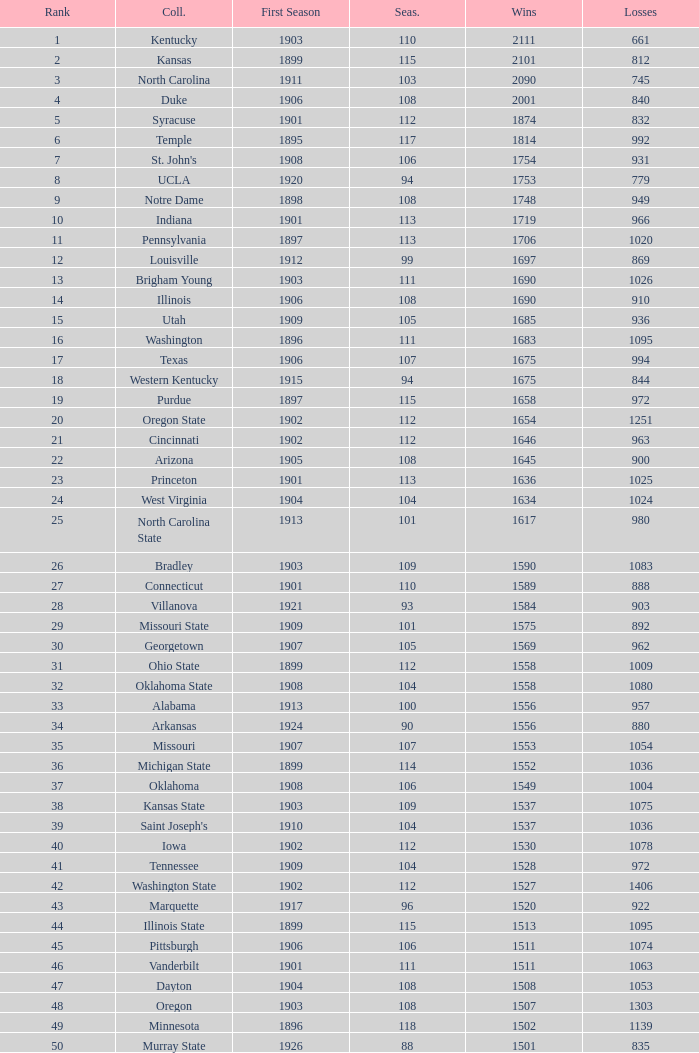What is the total of First Season games with 1537 Wins and a Season greater than 109? None. 